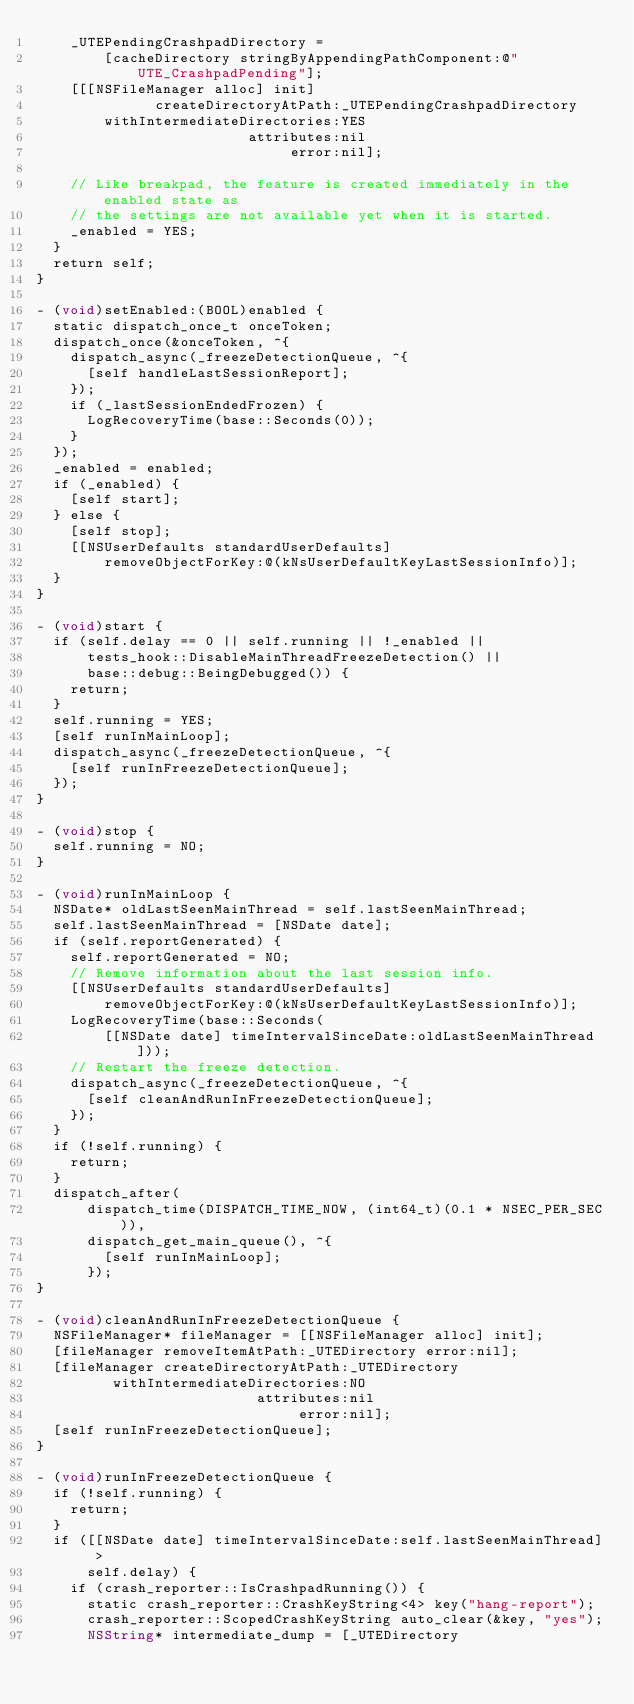Convert code to text. <code><loc_0><loc_0><loc_500><loc_500><_ObjectiveC_>    _UTEPendingCrashpadDirectory =
        [cacheDirectory stringByAppendingPathComponent:@"UTE_CrashpadPending"];
    [[[NSFileManager alloc] init]
              createDirectoryAtPath:_UTEPendingCrashpadDirectory
        withIntermediateDirectories:YES
                         attributes:nil
                              error:nil];

    // Like breakpad, the feature is created immediately in the enabled state as
    // the settings are not available yet when it is started.
    _enabled = YES;
  }
  return self;
}

- (void)setEnabled:(BOOL)enabled {
  static dispatch_once_t onceToken;
  dispatch_once(&onceToken, ^{
    dispatch_async(_freezeDetectionQueue, ^{
      [self handleLastSessionReport];
    });
    if (_lastSessionEndedFrozen) {
      LogRecoveryTime(base::Seconds(0));
    }
  });
  _enabled = enabled;
  if (_enabled) {
    [self start];
  } else {
    [self stop];
    [[NSUserDefaults standardUserDefaults]
        removeObjectForKey:@(kNsUserDefaultKeyLastSessionInfo)];
  }
}

- (void)start {
  if (self.delay == 0 || self.running || !_enabled ||
      tests_hook::DisableMainThreadFreezeDetection() ||
      base::debug::BeingDebugged()) {
    return;
  }
  self.running = YES;
  [self runInMainLoop];
  dispatch_async(_freezeDetectionQueue, ^{
    [self runInFreezeDetectionQueue];
  });
}

- (void)stop {
  self.running = NO;
}

- (void)runInMainLoop {
  NSDate* oldLastSeenMainThread = self.lastSeenMainThread;
  self.lastSeenMainThread = [NSDate date];
  if (self.reportGenerated) {
    self.reportGenerated = NO;
    // Remove information about the last session info.
    [[NSUserDefaults standardUserDefaults]
        removeObjectForKey:@(kNsUserDefaultKeyLastSessionInfo)];
    LogRecoveryTime(base::Seconds(
        [[NSDate date] timeIntervalSinceDate:oldLastSeenMainThread]));
    // Restart the freeze detection.
    dispatch_async(_freezeDetectionQueue, ^{
      [self cleanAndRunInFreezeDetectionQueue];
    });
  }
  if (!self.running) {
    return;
  }
  dispatch_after(
      dispatch_time(DISPATCH_TIME_NOW, (int64_t)(0.1 * NSEC_PER_SEC)),
      dispatch_get_main_queue(), ^{
        [self runInMainLoop];
      });
}

- (void)cleanAndRunInFreezeDetectionQueue {
  NSFileManager* fileManager = [[NSFileManager alloc] init];
  [fileManager removeItemAtPath:_UTEDirectory error:nil];
  [fileManager createDirectoryAtPath:_UTEDirectory
         withIntermediateDirectories:NO
                          attributes:nil
                               error:nil];
  [self runInFreezeDetectionQueue];
}

- (void)runInFreezeDetectionQueue {
  if (!self.running) {
    return;
  }
  if ([[NSDate date] timeIntervalSinceDate:self.lastSeenMainThread] >
      self.delay) {
    if (crash_reporter::IsCrashpadRunning()) {
      static crash_reporter::CrashKeyString<4> key("hang-report");
      crash_reporter::ScopedCrashKeyString auto_clear(&key, "yes");
      NSString* intermediate_dump = [_UTEDirectory</code> 